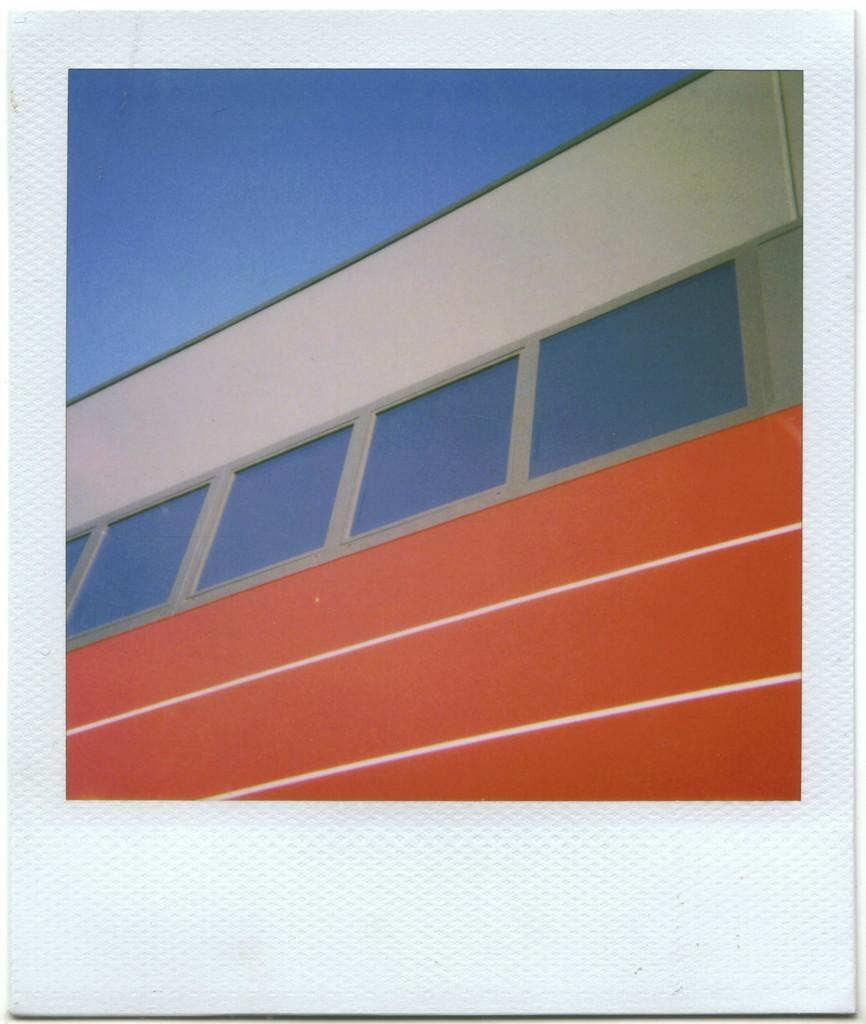What object is present in the image that might be used for cleaning or wiping? There is a tissue paper in the image. What is depicted on the tissue paper? There is a picture of a wall on the tissue paper. What type of jellyfish can be seen swimming in the image? There is no jellyfish present in the image; it only features a tissue paper with a picture of a wall. 